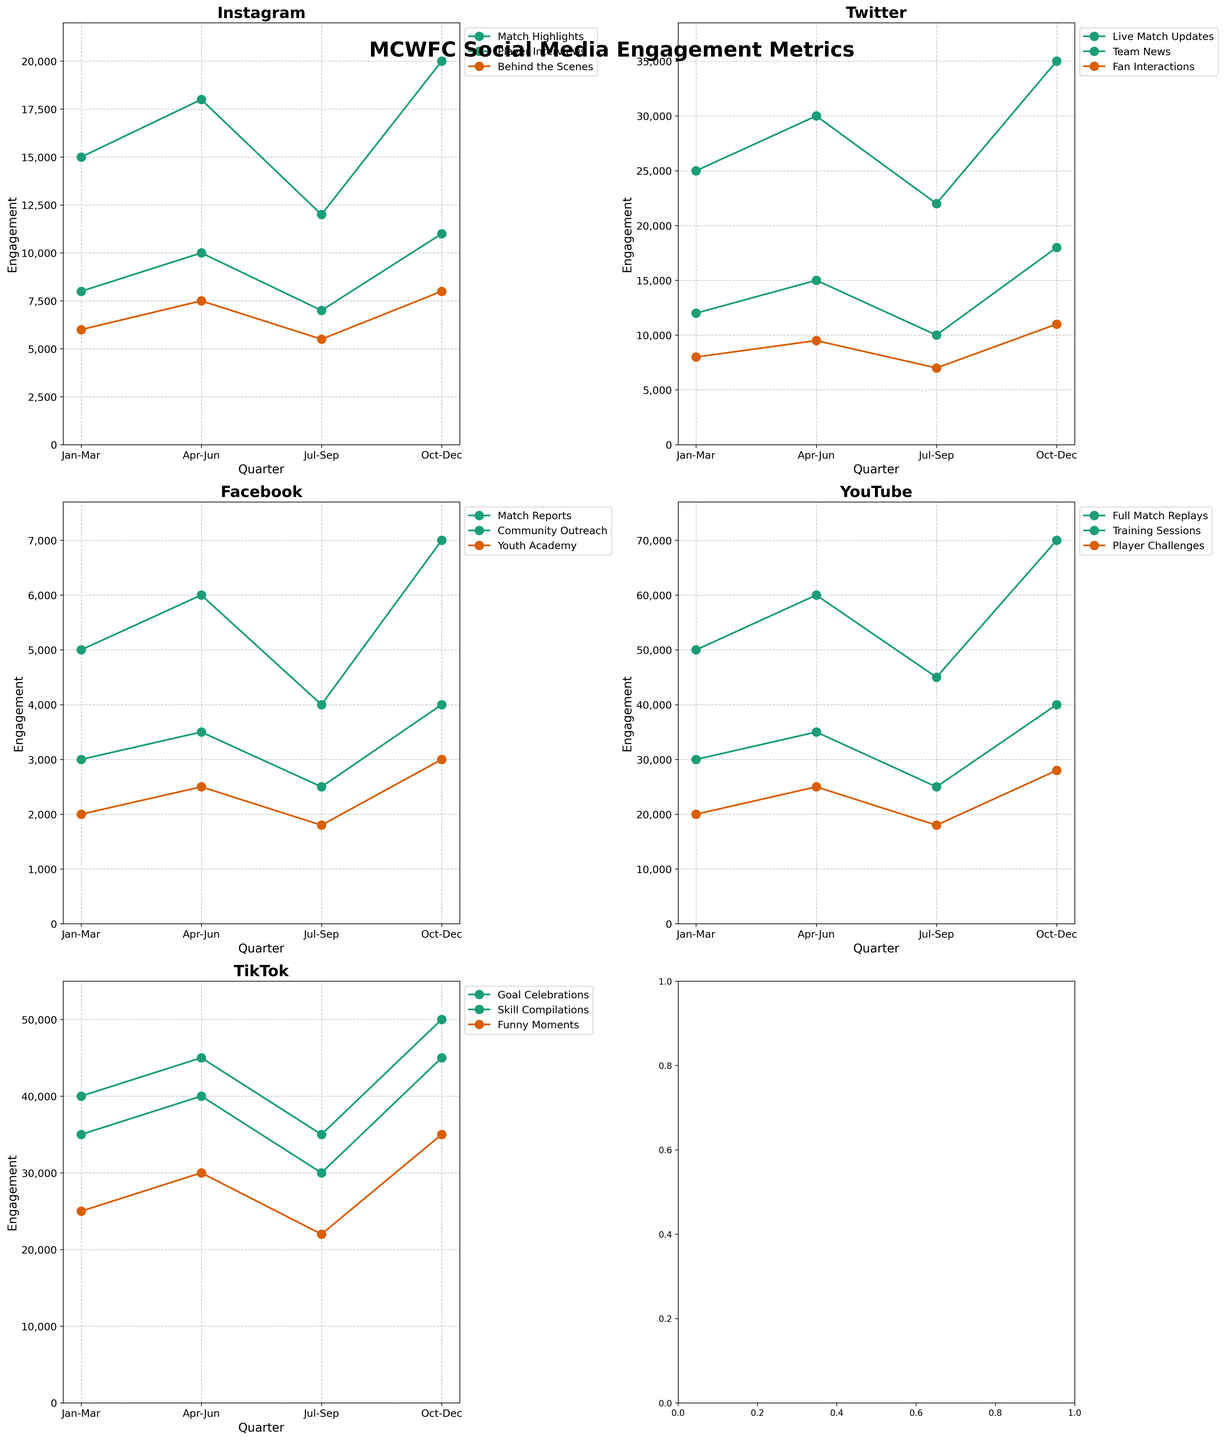What is the highest engagement for Full Match Replays on YouTube across all quarters? Find "YouTube" platform's "Full Match Replays" data. Note that highest value is 70,000 in Oct-Dec.
Answer: 70,000 Which platform and content type show the highest engagement in Oct-Dec? Check all platforms and content types for Oct-Dec. The highest value is 70,000 for Full Match Replays on YouTube.
Answer: YouTube, Full Match Replays What is the average engagement of Goal Celebrations on TikTok over the entire year? Add the engagements for each quarter for Goal Celebrations on TikTok (40,000 + 45,000 + 35,000 + 50,000), then divide by 4. (170,000 / 4 = 42,500)
Answer: 42,500 How did engagement for Live Match Updates on Twitter change from Jan-Mar to Jul-Sep? Subtract engagement in Jan-Mar (25,000) from engagement in Jul-Sep (22,000). (-3,000)
Answer: Decreased by 3,000 Which content type had the lowest engagement on Facebook in Apr-Jun? Compare engagements for all content types on Facebook in Apr-Jun (Match Reports: 6,000, Community Outreach: 3,500, Youth Academy: 2,500). The lowest is Youth Academy.
Answer: Youth Academy What is the total engagement for Player Interviews on Instagram across all quarters? Sum engagements for each quarter for Player Interviews on Instagram (8,000 + 10,000 + 7,000 + 11,000). (36,000)
Answer: 36,000 Between Match Highlights on Instagram and Skill Compilations on TikTok, which had higher engagement in Jan-Mar and what were the values? Compare Jan-Mar engagements (Instagram Match Highlights: 15,000, TikTok Skill Compilations: 35,000). Skill Compilations had higher engagement at 35,000.
Answer: Skill Compilations, 35,000 Which quarter shows the highest engagement for all content types on Instagram? Sum engagements for each quarter on Instagram (Jan-Mar: 29,000, Apr-Jun: 35,500, Jul-Sep: 24,500, Oct-Dec: 39,000). Oct-Dec shows the highest with 39,000.
Answer: Oct-Dec Did engagements for Training Sessions on YouTube increase or decrease from Jul-Sep to Oct-Dec? Compare engagements for Training Sessions on YouTube (Jul-Sep: 25,000, Oct-Dec: 40,000). It increased.
Answer: Increased Which content type on Twitter has the most consistent engagement throughout the year? Check engagement trends for each content type on Twitter and note the variability. Live Match Updates has the most consistently high engagement (25,000-35,000).
Answer: Live Match Updates 